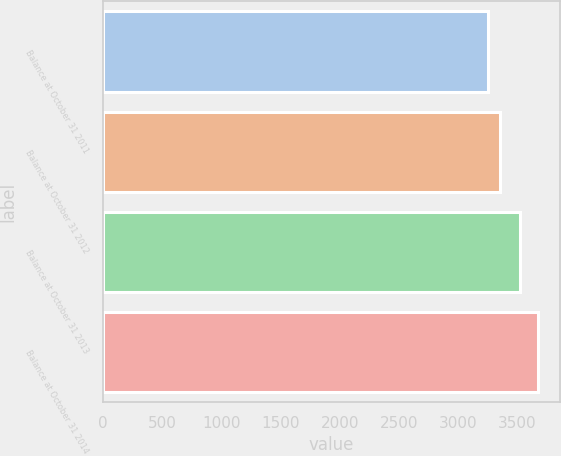Convert chart to OTSL. <chart><loc_0><loc_0><loc_500><loc_500><bar_chart><fcel>Balance at October 31 2011<fcel>Balance at October 31 2012<fcel>Balance at October 31 2013<fcel>Balance at October 31 2014<nl><fcel>3252<fcel>3352<fcel>3524<fcel>3675<nl></chart> 